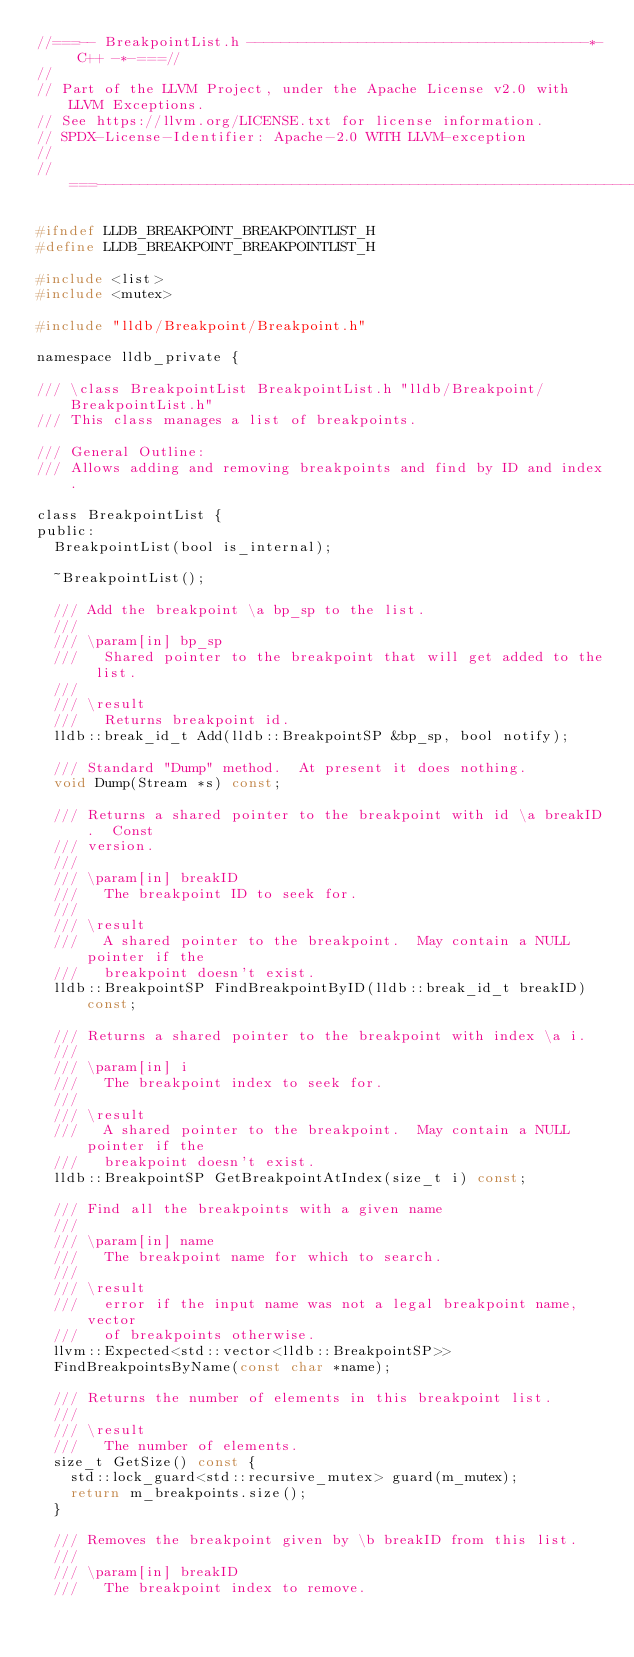Convert code to text. <code><loc_0><loc_0><loc_500><loc_500><_C_>//===-- BreakpointList.h ----------------------------------------*- C++ -*-===//
//
// Part of the LLVM Project, under the Apache License v2.0 with LLVM Exceptions.
// See https://llvm.org/LICENSE.txt for license information.
// SPDX-License-Identifier: Apache-2.0 WITH LLVM-exception
//
//===----------------------------------------------------------------------===//

#ifndef LLDB_BREAKPOINT_BREAKPOINTLIST_H
#define LLDB_BREAKPOINT_BREAKPOINTLIST_H

#include <list>
#include <mutex>

#include "lldb/Breakpoint/Breakpoint.h"

namespace lldb_private {

/// \class BreakpointList BreakpointList.h "lldb/Breakpoint/BreakpointList.h"
/// This class manages a list of breakpoints.

/// General Outline:
/// Allows adding and removing breakpoints and find by ID and index.

class BreakpointList {
public:
  BreakpointList(bool is_internal);

  ~BreakpointList();

  /// Add the breakpoint \a bp_sp to the list.
  ///
  /// \param[in] bp_sp
  ///   Shared pointer to the breakpoint that will get added to the list.
  ///
  /// \result
  ///   Returns breakpoint id.
  lldb::break_id_t Add(lldb::BreakpointSP &bp_sp, bool notify);

  /// Standard "Dump" method.  At present it does nothing.
  void Dump(Stream *s) const;

  /// Returns a shared pointer to the breakpoint with id \a breakID.  Const
  /// version.
  ///
  /// \param[in] breakID
  ///   The breakpoint ID to seek for.
  ///
  /// \result
  ///   A shared pointer to the breakpoint.  May contain a NULL pointer if the
  ///   breakpoint doesn't exist.
  lldb::BreakpointSP FindBreakpointByID(lldb::break_id_t breakID) const;

  /// Returns a shared pointer to the breakpoint with index \a i.
  ///
  /// \param[in] i
  ///   The breakpoint index to seek for.
  ///
  /// \result
  ///   A shared pointer to the breakpoint.  May contain a NULL pointer if the
  ///   breakpoint doesn't exist.
  lldb::BreakpointSP GetBreakpointAtIndex(size_t i) const;

  /// Find all the breakpoints with a given name
  ///
  /// \param[in] name
  ///   The breakpoint name for which to search.
  ///
  /// \result
  ///   error if the input name was not a legal breakpoint name, vector
  ///   of breakpoints otherwise.
  llvm::Expected<std::vector<lldb::BreakpointSP>>
  FindBreakpointsByName(const char *name);

  /// Returns the number of elements in this breakpoint list.
  ///
  /// \result
  ///   The number of elements.
  size_t GetSize() const {
    std::lock_guard<std::recursive_mutex> guard(m_mutex);
    return m_breakpoints.size();
  }

  /// Removes the breakpoint given by \b breakID from this list.
  ///
  /// \param[in] breakID
  ///   The breakpoint index to remove.</code> 